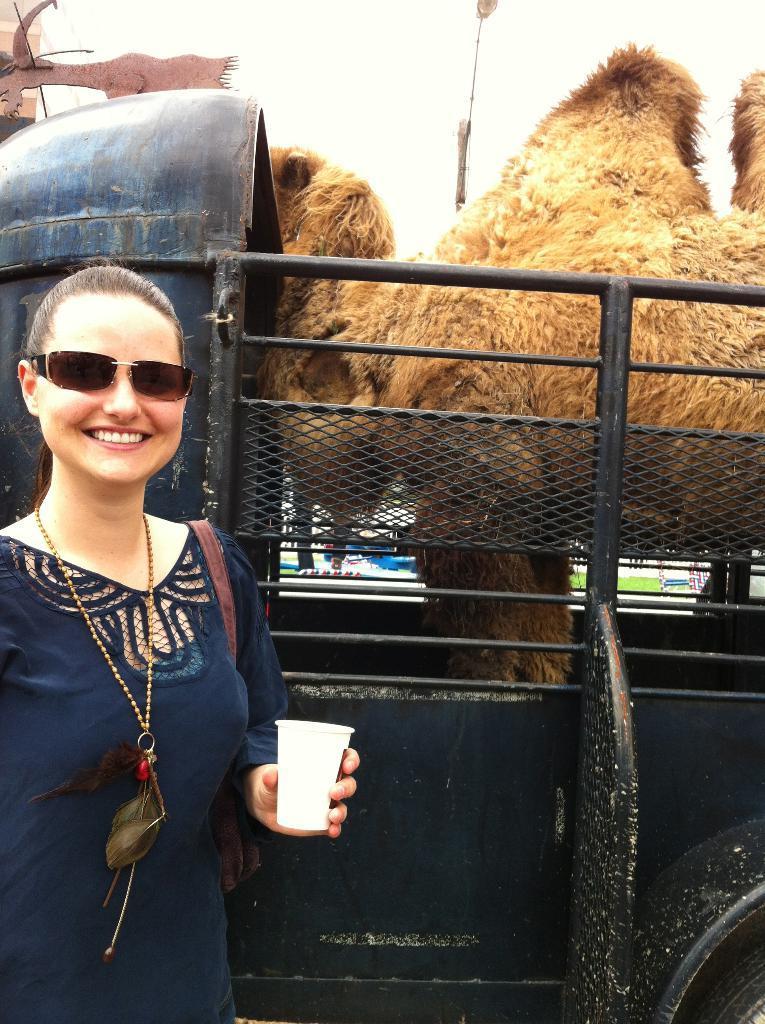Describe this image in one or two sentences. In the picture I can see a woman wearing black color dress, chain and glasses is smiling and holding a cup and standing on the left side of the image. In the background, I can see an animal in the vehicle and the sky. 